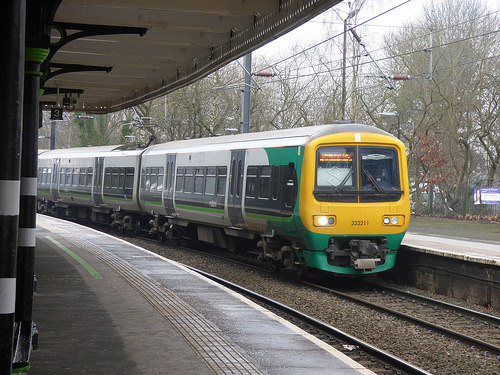<image>
Can you confirm if the train is above the track? No. The train is not positioned above the track. The vertical arrangement shows a different relationship. 